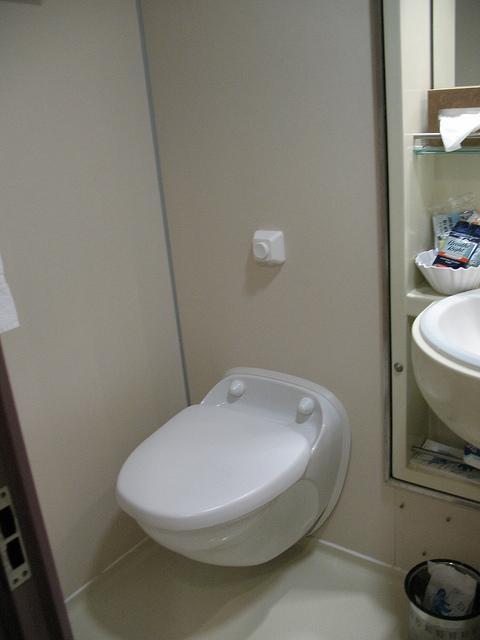How many toilets can be seen?
Give a very brief answer. 1. How many sinks are in the photo?
Give a very brief answer. 1. How many cars can you see?
Give a very brief answer. 0. 